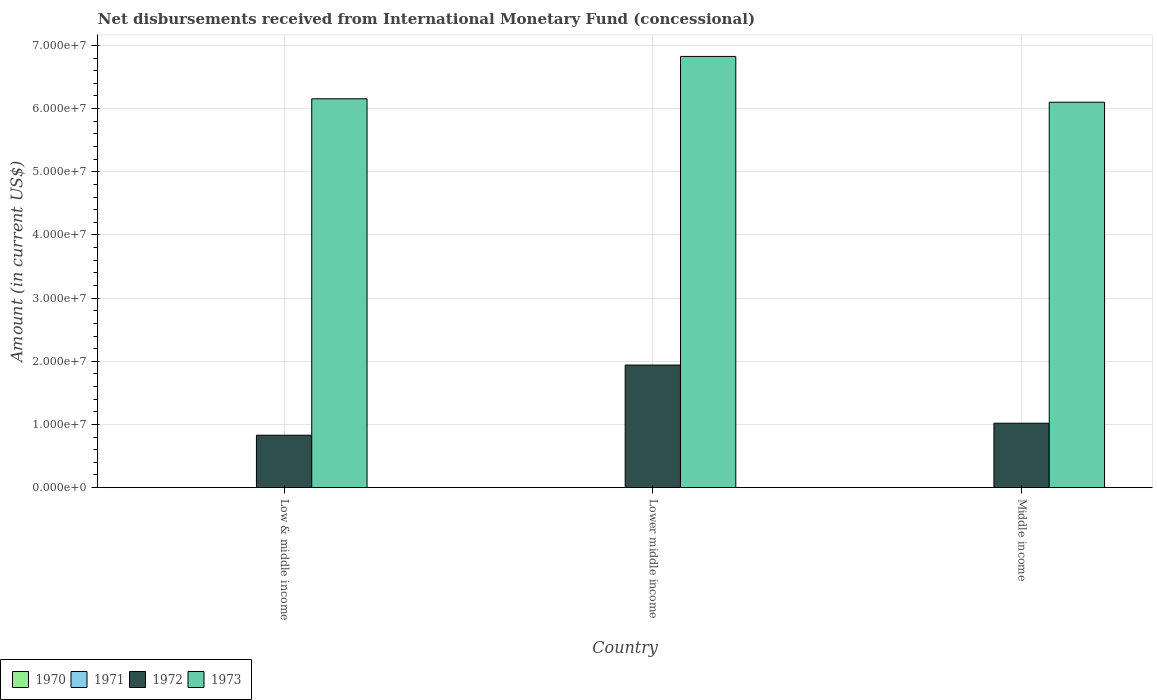How many different coloured bars are there?
Your response must be concise. 2. How many groups of bars are there?
Your answer should be compact. 3. Are the number of bars on each tick of the X-axis equal?
Keep it short and to the point. Yes. How many bars are there on the 3rd tick from the right?
Offer a very short reply. 2. What is the amount of disbursements received from International Monetary Fund in 1972 in Lower middle income?
Make the answer very short. 1.94e+07. Across all countries, what is the maximum amount of disbursements received from International Monetary Fund in 1972?
Make the answer very short. 1.94e+07. Across all countries, what is the minimum amount of disbursements received from International Monetary Fund in 1973?
Offer a very short reply. 6.10e+07. In which country was the amount of disbursements received from International Monetary Fund in 1973 maximum?
Your answer should be very brief. Lower middle income. What is the total amount of disbursements received from International Monetary Fund in 1973 in the graph?
Your answer should be very brief. 1.91e+08. What is the difference between the amount of disbursements received from International Monetary Fund in 1973 in Low & middle income and that in Lower middle income?
Ensure brevity in your answer.  -6.70e+06. What is the difference between the amount of disbursements received from International Monetary Fund in 1972 in Low & middle income and the amount of disbursements received from International Monetary Fund in 1973 in Middle income?
Keep it short and to the point. -5.27e+07. What is the average amount of disbursements received from International Monetary Fund in 1972 per country?
Offer a terse response. 1.26e+07. What is the ratio of the amount of disbursements received from International Monetary Fund in 1972 in Lower middle income to that in Middle income?
Give a very brief answer. 1.9. Is the amount of disbursements received from International Monetary Fund in 1973 in Low & middle income less than that in Lower middle income?
Offer a very short reply. Yes. What is the difference between the highest and the second highest amount of disbursements received from International Monetary Fund in 1973?
Provide a short and direct response. -7.25e+06. What is the difference between the highest and the lowest amount of disbursements received from International Monetary Fund in 1973?
Ensure brevity in your answer.  7.25e+06. Is it the case that in every country, the sum of the amount of disbursements received from International Monetary Fund in 1971 and amount of disbursements received from International Monetary Fund in 1970 is greater than the amount of disbursements received from International Monetary Fund in 1973?
Give a very brief answer. No. What is the difference between two consecutive major ticks on the Y-axis?
Ensure brevity in your answer.  1.00e+07. Are the values on the major ticks of Y-axis written in scientific E-notation?
Offer a terse response. Yes. Does the graph contain grids?
Keep it short and to the point. Yes. How are the legend labels stacked?
Offer a very short reply. Horizontal. What is the title of the graph?
Keep it short and to the point. Net disbursements received from International Monetary Fund (concessional). What is the label or title of the X-axis?
Your response must be concise. Country. What is the label or title of the Y-axis?
Give a very brief answer. Amount (in current US$). What is the Amount (in current US$) in 1970 in Low & middle income?
Keep it short and to the point. 0. What is the Amount (in current US$) in 1972 in Low & middle income?
Provide a succinct answer. 8.30e+06. What is the Amount (in current US$) in 1973 in Low & middle income?
Your response must be concise. 6.16e+07. What is the Amount (in current US$) of 1970 in Lower middle income?
Make the answer very short. 0. What is the Amount (in current US$) of 1972 in Lower middle income?
Your answer should be compact. 1.94e+07. What is the Amount (in current US$) in 1973 in Lower middle income?
Ensure brevity in your answer.  6.83e+07. What is the Amount (in current US$) of 1970 in Middle income?
Give a very brief answer. 0. What is the Amount (in current US$) in 1972 in Middle income?
Your answer should be very brief. 1.02e+07. What is the Amount (in current US$) of 1973 in Middle income?
Keep it short and to the point. 6.10e+07. Across all countries, what is the maximum Amount (in current US$) of 1972?
Keep it short and to the point. 1.94e+07. Across all countries, what is the maximum Amount (in current US$) in 1973?
Your response must be concise. 6.83e+07. Across all countries, what is the minimum Amount (in current US$) in 1972?
Provide a short and direct response. 8.30e+06. Across all countries, what is the minimum Amount (in current US$) in 1973?
Offer a terse response. 6.10e+07. What is the total Amount (in current US$) in 1972 in the graph?
Your response must be concise. 3.79e+07. What is the total Amount (in current US$) in 1973 in the graph?
Ensure brevity in your answer.  1.91e+08. What is the difference between the Amount (in current US$) in 1972 in Low & middle income and that in Lower middle income?
Offer a very short reply. -1.11e+07. What is the difference between the Amount (in current US$) in 1973 in Low & middle income and that in Lower middle income?
Ensure brevity in your answer.  -6.70e+06. What is the difference between the Amount (in current US$) in 1972 in Low & middle income and that in Middle income?
Provide a short and direct response. -1.90e+06. What is the difference between the Amount (in current US$) of 1973 in Low & middle income and that in Middle income?
Offer a terse response. 5.46e+05. What is the difference between the Amount (in current US$) of 1972 in Lower middle income and that in Middle income?
Keep it short and to the point. 9.21e+06. What is the difference between the Amount (in current US$) of 1973 in Lower middle income and that in Middle income?
Offer a very short reply. 7.25e+06. What is the difference between the Amount (in current US$) in 1972 in Low & middle income and the Amount (in current US$) in 1973 in Lower middle income?
Give a very brief answer. -6.00e+07. What is the difference between the Amount (in current US$) in 1972 in Low & middle income and the Amount (in current US$) in 1973 in Middle income?
Your response must be concise. -5.27e+07. What is the difference between the Amount (in current US$) in 1972 in Lower middle income and the Amount (in current US$) in 1973 in Middle income?
Provide a short and direct response. -4.16e+07. What is the average Amount (in current US$) in 1970 per country?
Offer a very short reply. 0. What is the average Amount (in current US$) in 1972 per country?
Make the answer very short. 1.26e+07. What is the average Amount (in current US$) in 1973 per country?
Ensure brevity in your answer.  6.36e+07. What is the difference between the Amount (in current US$) of 1972 and Amount (in current US$) of 1973 in Low & middle income?
Offer a very short reply. -5.33e+07. What is the difference between the Amount (in current US$) in 1972 and Amount (in current US$) in 1973 in Lower middle income?
Make the answer very short. -4.89e+07. What is the difference between the Amount (in current US$) in 1972 and Amount (in current US$) in 1973 in Middle income?
Give a very brief answer. -5.08e+07. What is the ratio of the Amount (in current US$) in 1972 in Low & middle income to that in Lower middle income?
Ensure brevity in your answer.  0.43. What is the ratio of the Amount (in current US$) in 1973 in Low & middle income to that in Lower middle income?
Provide a short and direct response. 0.9. What is the ratio of the Amount (in current US$) of 1972 in Low & middle income to that in Middle income?
Ensure brevity in your answer.  0.81. What is the ratio of the Amount (in current US$) in 1972 in Lower middle income to that in Middle income?
Your answer should be very brief. 1.9. What is the ratio of the Amount (in current US$) of 1973 in Lower middle income to that in Middle income?
Keep it short and to the point. 1.12. What is the difference between the highest and the second highest Amount (in current US$) in 1972?
Give a very brief answer. 9.21e+06. What is the difference between the highest and the second highest Amount (in current US$) of 1973?
Provide a succinct answer. 6.70e+06. What is the difference between the highest and the lowest Amount (in current US$) in 1972?
Offer a very short reply. 1.11e+07. What is the difference between the highest and the lowest Amount (in current US$) of 1973?
Your answer should be very brief. 7.25e+06. 